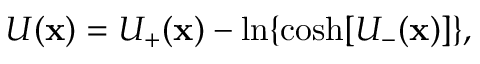<formula> <loc_0><loc_0><loc_500><loc_500>U ( x ) = U _ { + } ( x ) - \ln \{ \cosh [ U _ { - } ( x ) ] \} ,</formula> 